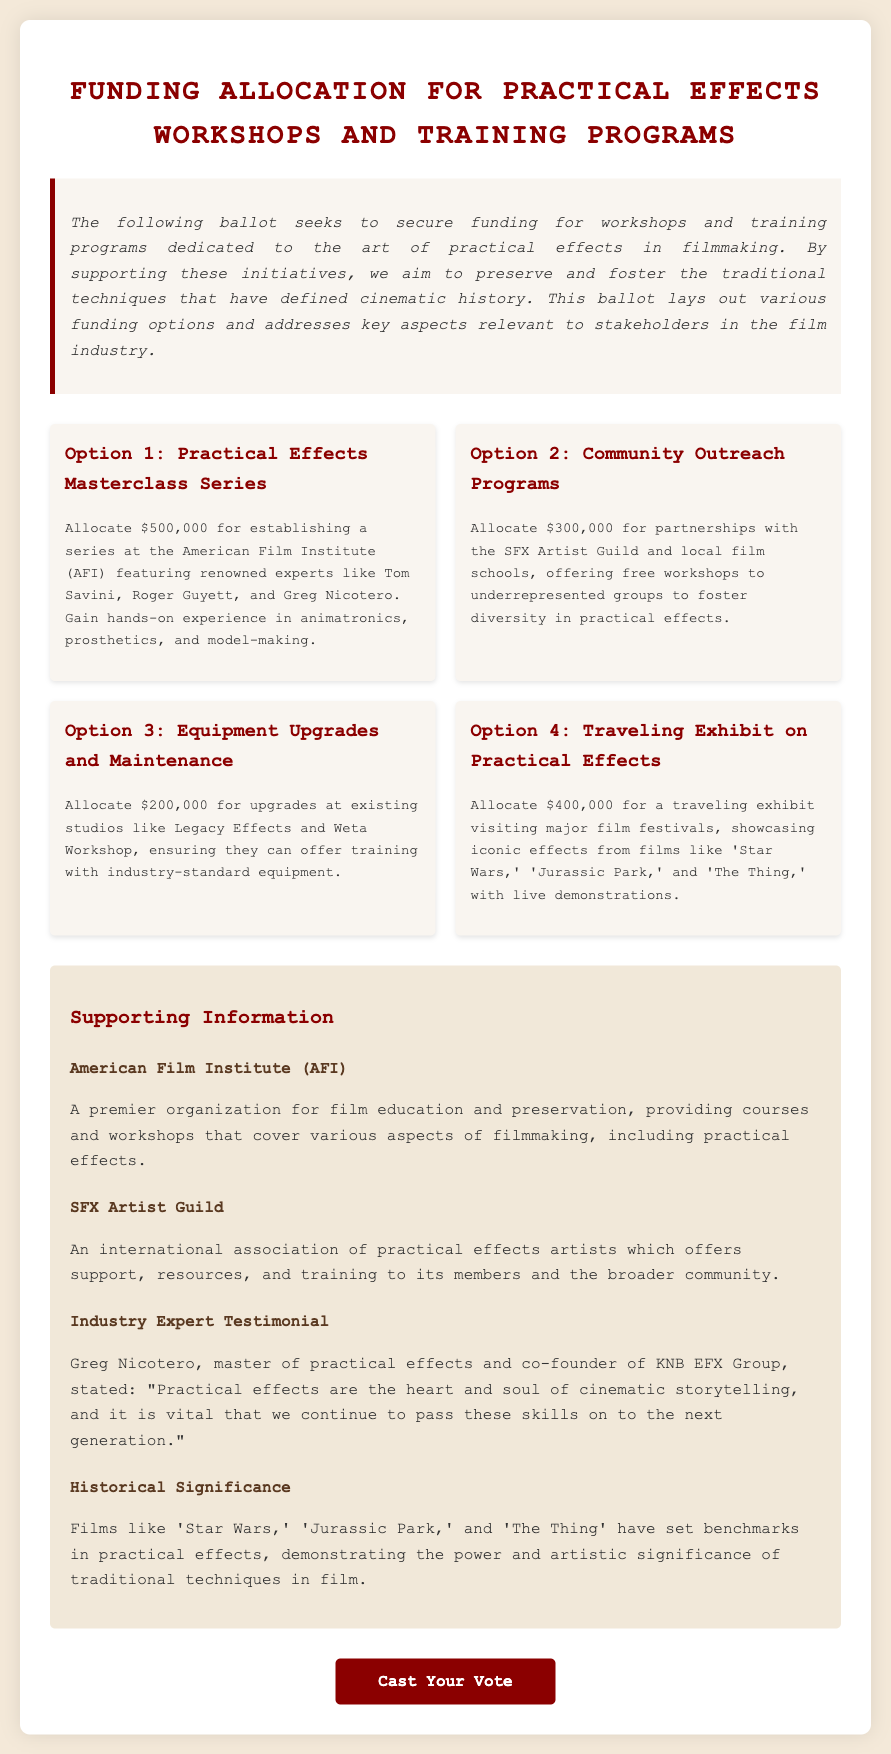What is the total funding amount for Option 1? Option 1 proposes allocating $500,000 for the Practical Effects Masterclass Series.
Answer: $500,000 Who are the featured experts in Option 1? Option 1 mentions renowned experts like Tom Savini, Roger Guyett, and Greg Nicotero.
Answer: Tom Savini, Roger Guyett, and Greg Nicotero What is the funding amount for the Community Outreach Programs? The document states that Option 2 allocates $300,000 for Community Outreach Programs.
Answer: $300,000 What is the purpose of the Traveling Exhibit on Practical Effects? Option 4 describes a traveling exhibit that showcases iconic effects from films, emphasizing their significance in practical effects.
Answer: Showcase iconic effects How much funding is proposed for Equipment Upgrades and Maintenance? Option 3 requests $200,000 for upgrades at existing studios.
Answer: $200,000 What organization is mentioned as a premier film education institution? The document refers to the American Film Institute (AFI) as a leading organization in film education.
Answer: American Film Institute (AFI) Who provided a testimonial supporting practical effects? The document cites Greg Nicotero, a master of practical effects, as the source of the testimonial.
Answer: Greg Nicotero What is the historical significance of films like 'Star Wars'? The document notes that these films have set benchmarks in practical effects, highlighting their artistic importance.
Answer: Set benchmarks in practical effects What is the primary goal of the funding ballot? The ballot aims to secure funding for workshops and training programs dedicated to practical effects in filmmaking.
Answer: Secure funding for workshops and training programs 